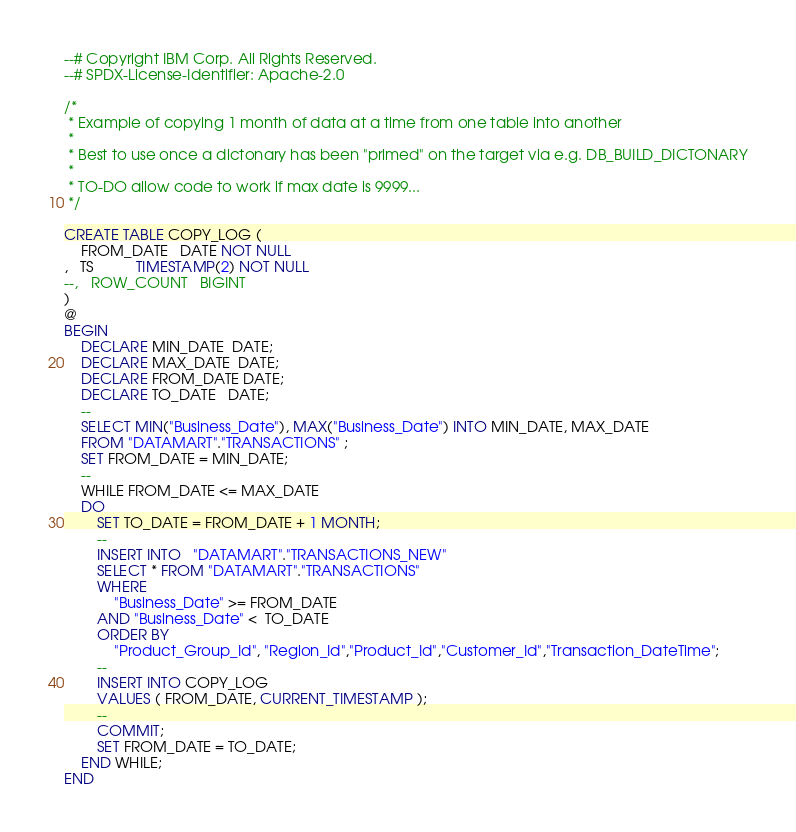<code> <loc_0><loc_0><loc_500><loc_500><_SQL_>--# Copyright IBM Corp. All Rights Reserved.
--# SPDX-License-Identifier: Apache-2.0

/*
 * Example of copying 1 month of data at a time from one table into another
 * 
 * Best to use once a dictonary has been "primed" on the target via e.g. DB_BUILD_DICTONARY
 * 
 * TO-DO allow code to work if max date is 9999...
 */

CREATE TABLE COPY_LOG (
    FROM_DATE   DATE NOT NULL    
,   TS          TIMESTAMP(2) NOT NULL
--,   ROW_COUNT   BIGINT
)
@
BEGIN
    DECLARE MIN_DATE  DATE;  
    DECLARE MAX_DATE  DATE;
    DECLARE FROM_DATE DATE;
    DECLARE TO_DATE   DATE;
    --
    SELECT MIN("Business_Date"), MAX("Business_Date") INTO MIN_DATE, MAX_DATE
    FROM "DATAMART"."TRANSACTIONS" ;
    SET FROM_DATE = MIN_DATE;
    --
    WHILE FROM_DATE <= MAX_DATE
    DO
        SET TO_DATE = FROM_DATE + 1 MONTH;
        --  
        INSERT INTO   "DATAMART"."TRANSACTIONS_NEW"
        SELECT * FROM "DATAMART"."TRANSACTIONS"
        WHERE 
            "Business_Date" >= FROM_DATE
        AND "Business_Date" <  TO_DATE
        ORDER BY
            "Product_Group_Id", "Region_Id","Product_Id","Customer_Id","Transaction_DateTime";
        --
        INSERT INTO COPY_LOG
        VALUES ( FROM_DATE, CURRENT_TIMESTAMP );
        --
        COMMIT;
        SET FROM_DATE = TO_DATE;
    END WHILE;
END
</code> 